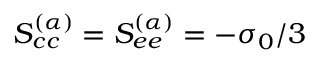Convert formula to latex. <formula><loc_0><loc_0><loc_500><loc_500>S _ { c c } ^ { ( \alpha ) } = S _ { e e } ^ { ( \alpha ) } = - \sigma _ { 0 } / 3</formula> 